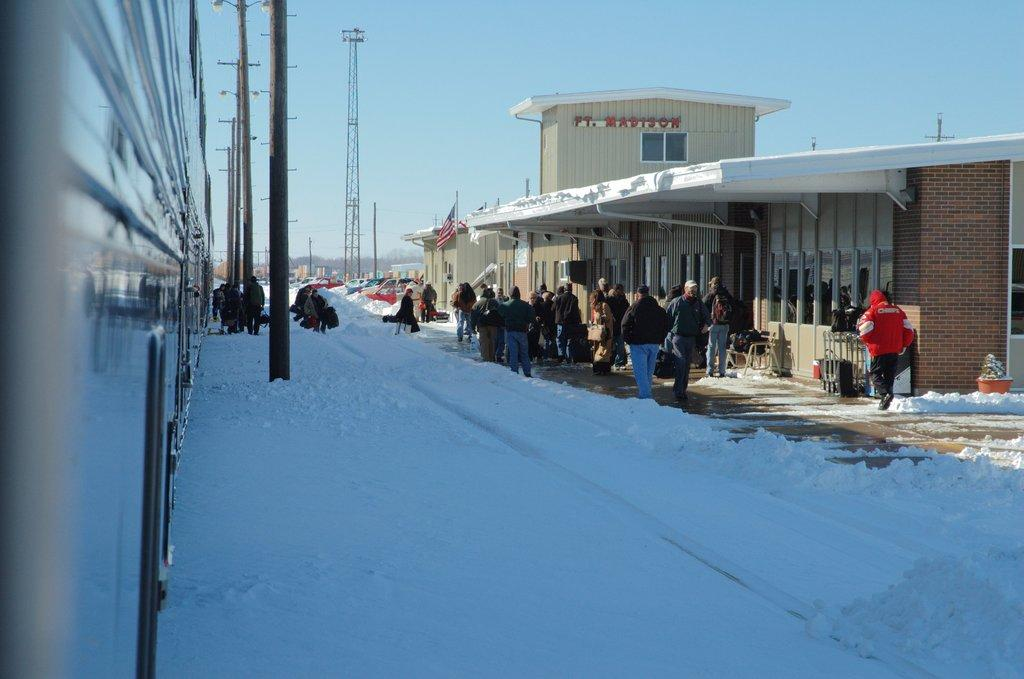What is the main feature of the landscape in the image? There is snow in the image. Who or what can be seen in the image? There are people in the image. What structures are present in the image? There are poles and buildings in the image. What can be seen in the background of the image? The sky is visible in the background of the image. How does the fireman twist the pin in the image? There is no fireman, twist, or pin present in the image. 